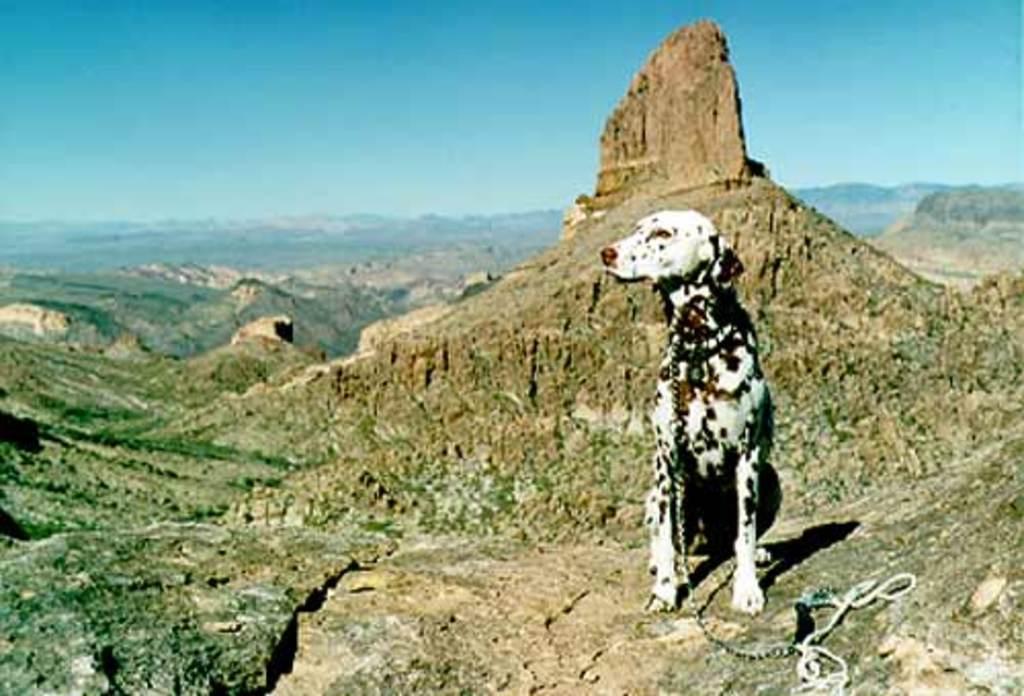Describe this image in one or two sentences. In this picture we can see a dog and a chain, in the background we can find few hills. 